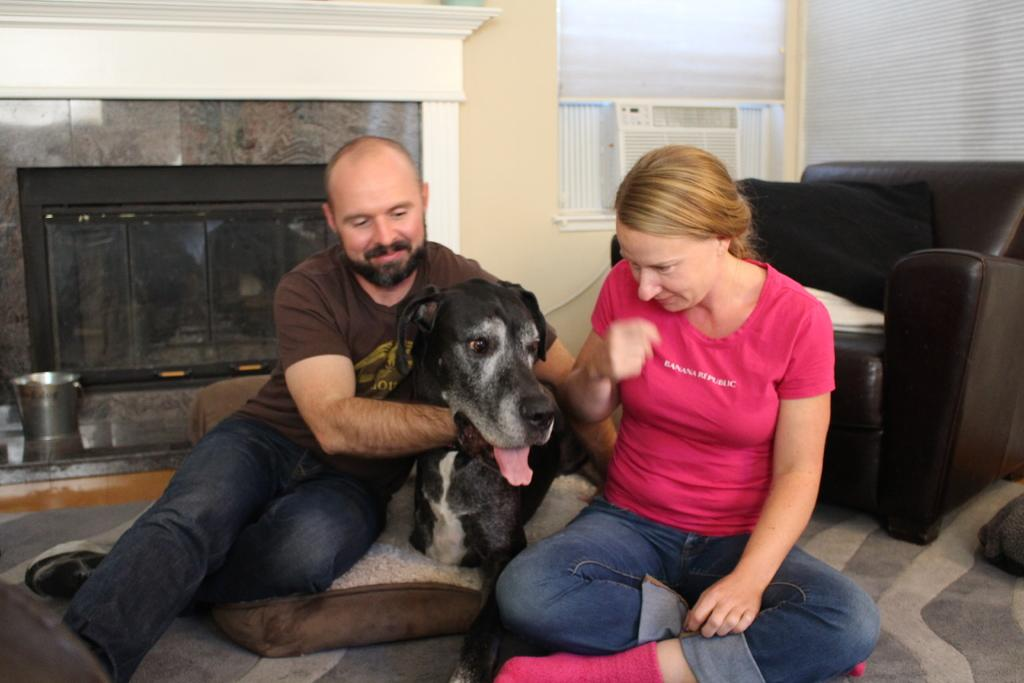How many people are in the image? There is a man and a woman in the image. What are the man and woman doing in the image? Both the man and woman are sitting on a carpet. What other living creature is present in the image? There is a dog in the image. What type of furniture can be seen in the image? There is a sofa in the image. Are there any accessories visible in the image? Yes, there is a pillow in the image. What other objects can be seen in the image? There is a bucket and a cloth in the image. What type of flesh can be seen on the pot in the image? There is no pot or flesh present in the image. What is the dog doing with its nose in the image? The image does not show the dog interacting with its nose; it is simply present in the image. 